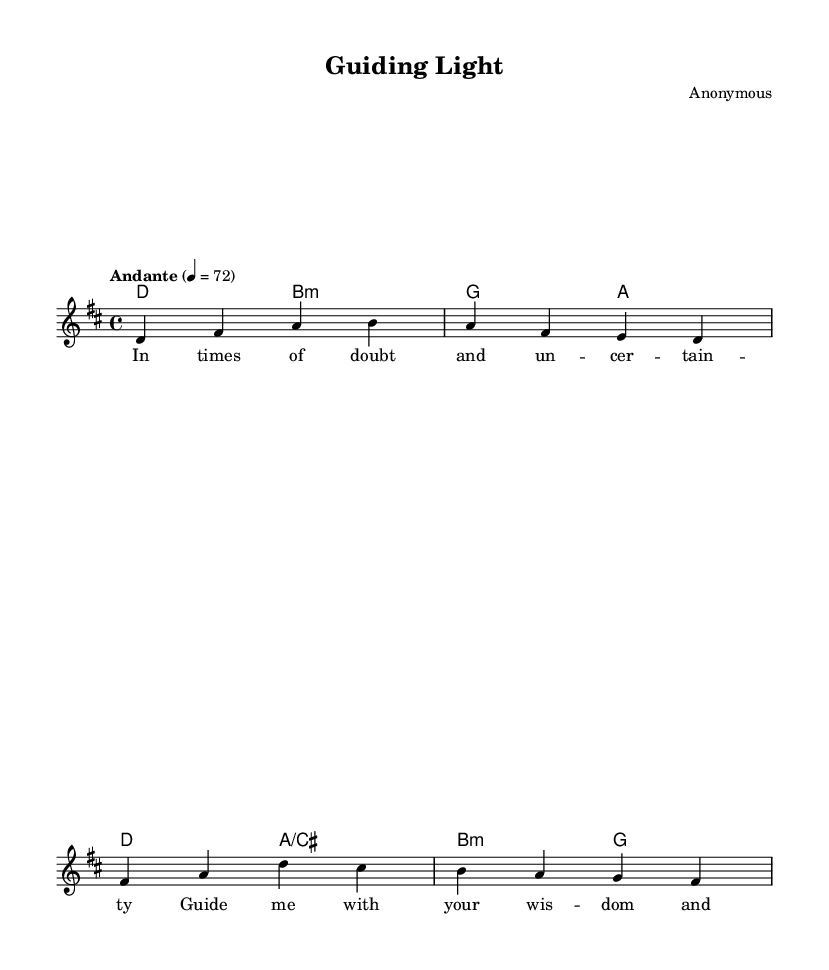What is the key signature of this music? The key signature is indicated by the number of sharps or flats at the beginning of the staff. In this case, it shows two sharps, which correspond to the key of D major.
Answer: D major What is the time signature of this music? The time signature is shown at the beginning of the staff as a fraction-like notation. Here, it is noted as 4/4, which means there are four beats per measure and a quarter note receives one beat.
Answer: 4/4 What is the tempo marking of this piece? The tempo marking can be found at the beginning of the score, indicating the speed at which the music should be played. Here, it is marked "Andante," which signifies a moderately slow tempo.
Answer: Andante How many measures are in the melody? By counting the individual groups of notes and rests from the start to the end of the melody line, we find that there are four measures represented in the provided melody section.
Answer: 4 What mood is conveyed by this music and its lyrics? The combination of the serene melody in D major, the gentle tempo marked as Andante, and the lyrics that speak of wisdom and guidance suggests a reflective and peaceful mood, ideal for meditative worship.
Answer: Reflective What is the purpose of the lyrics provided in this piece? The lyrics serve to complement the melody and express a plea for guidance and wisdom during times of doubt. This aligns with the purpose of meditative worship music, which seeks to inspire inner strength and clarity in decision-making.
Answer: To seek guidance 